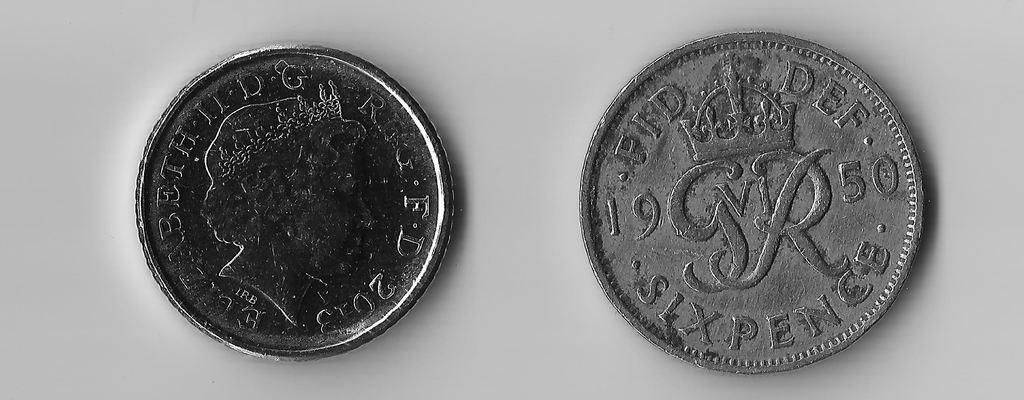Provide a one-sentence caption for the provided image. Two silver coins that say Beth II DG are on a white surface. 